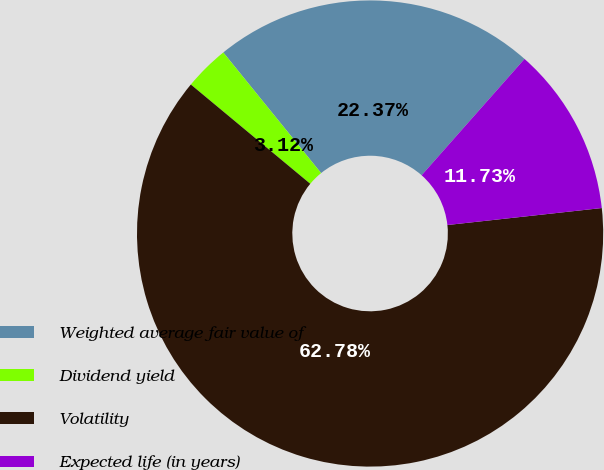Convert chart to OTSL. <chart><loc_0><loc_0><loc_500><loc_500><pie_chart><fcel>Weighted average fair value of<fcel>Dividend yield<fcel>Volatility<fcel>Expected life (in years)<nl><fcel>22.37%<fcel>3.12%<fcel>62.78%<fcel>11.73%<nl></chart> 